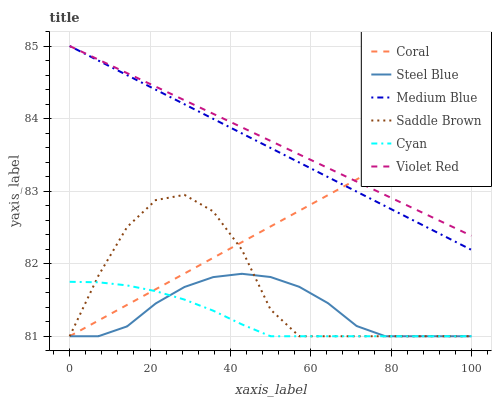Does Coral have the minimum area under the curve?
Answer yes or no. No. Does Coral have the maximum area under the curve?
Answer yes or no. No. Is Coral the smoothest?
Answer yes or no. No. Is Coral the roughest?
Answer yes or no. No. Does Medium Blue have the lowest value?
Answer yes or no. No. Does Coral have the highest value?
Answer yes or no. No. Is Saddle Brown less than Medium Blue?
Answer yes or no. Yes. Is Medium Blue greater than Cyan?
Answer yes or no. Yes. Does Saddle Brown intersect Medium Blue?
Answer yes or no. No. 